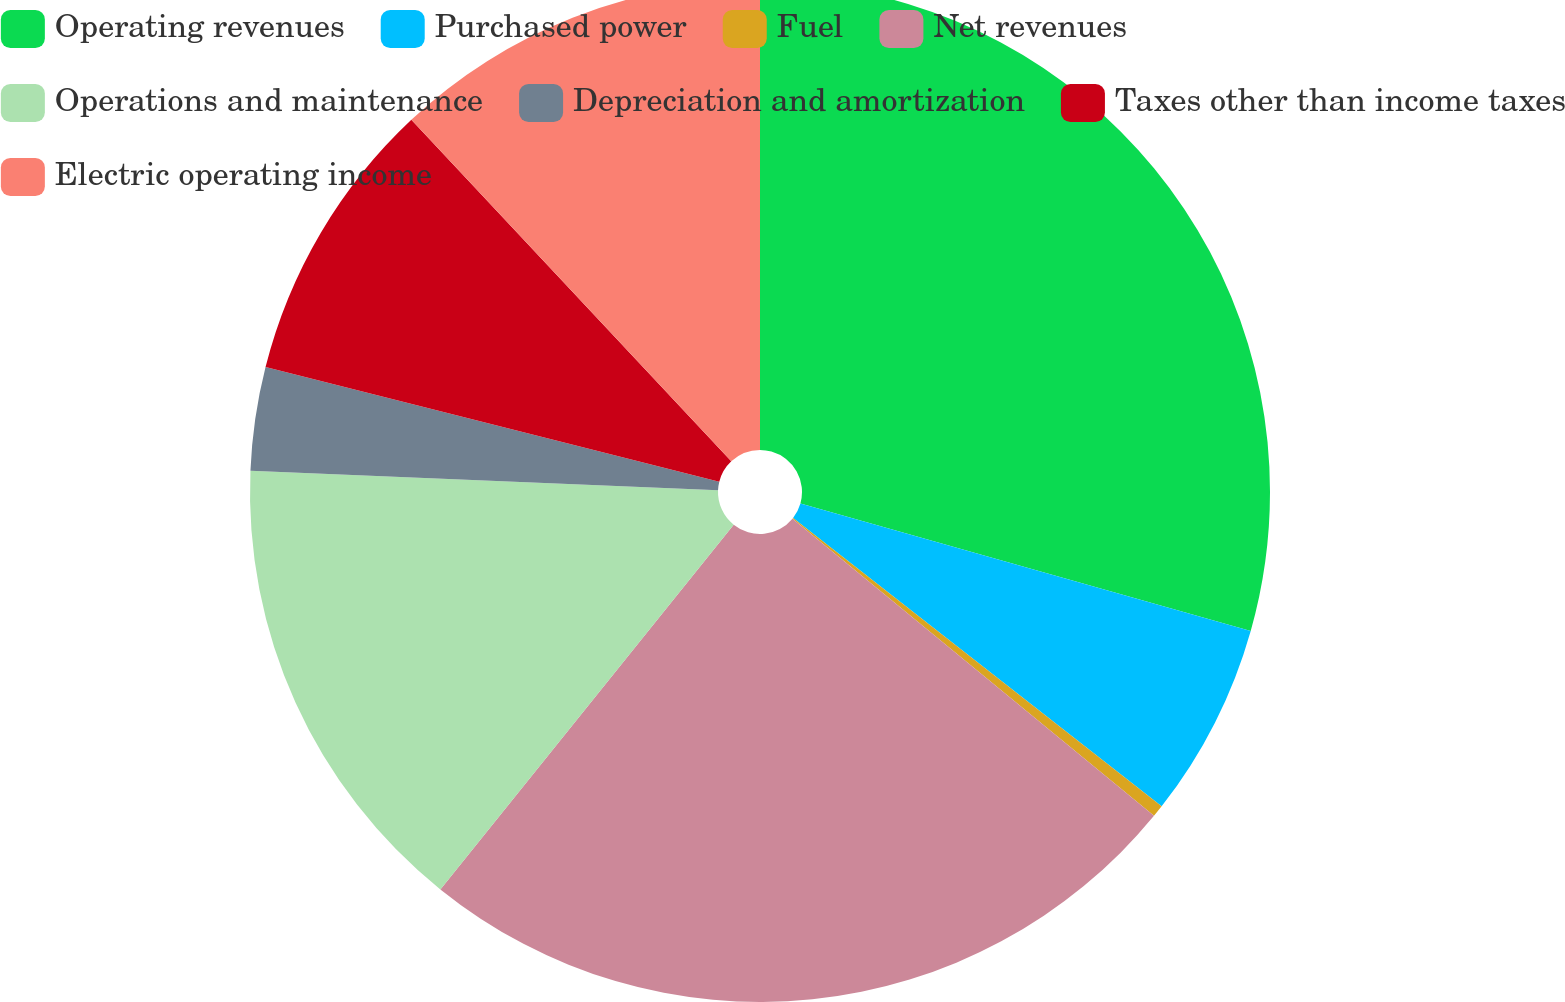Convert chart. <chart><loc_0><loc_0><loc_500><loc_500><pie_chart><fcel>Operating revenues<fcel>Purchased power<fcel>Fuel<fcel>Net revenues<fcel>Operations and maintenance<fcel>Depreciation and amortization<fcel>Taxes other than income taxes<fcel>Electric operating income<nl><fcel>29.39%<fcel>6.18%<fcel>0.38%<fcel>24.83%<fcel>14.88%<fcel>3.28%<fcel>9.08%<fcel>11.98%<nl></chart> 